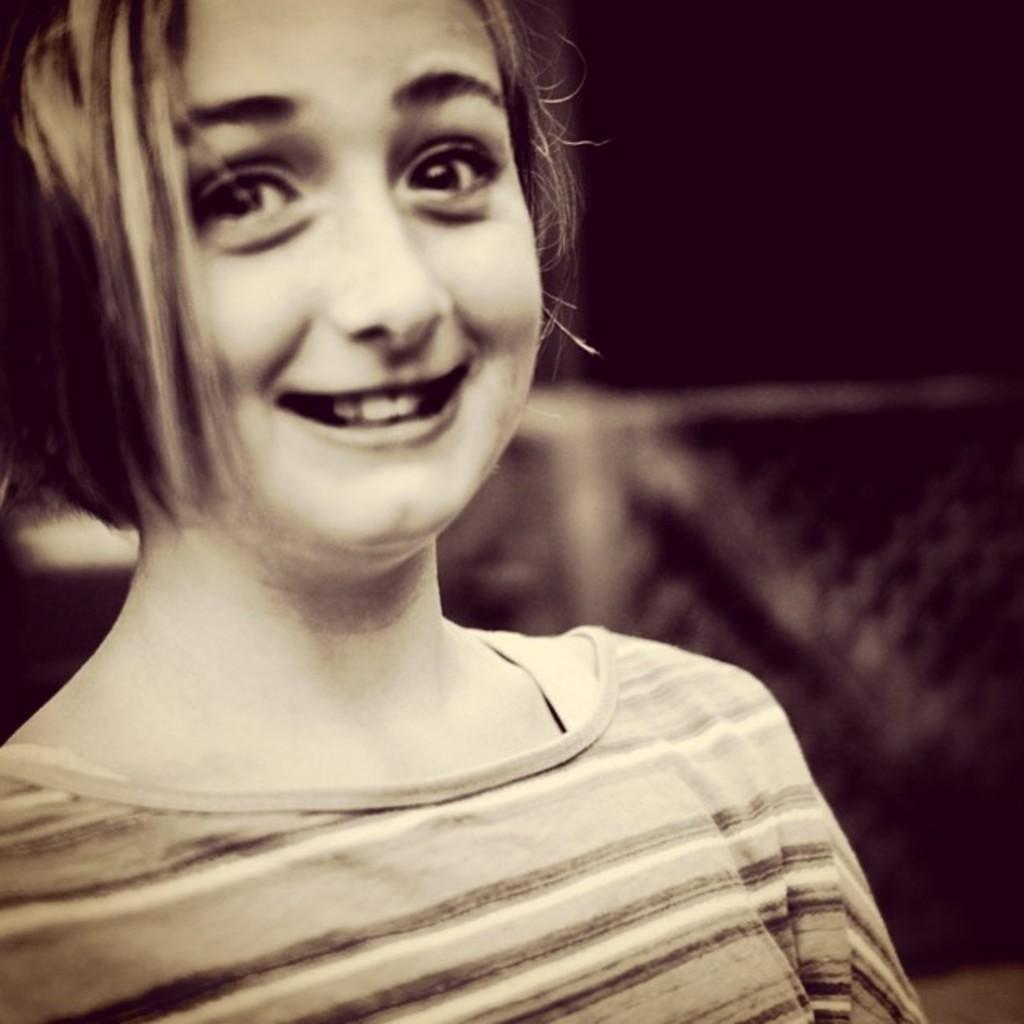How would you summarize this image in a sentence or two? This is a black and white image. In this image we can see a girl. In the background it is dark. 